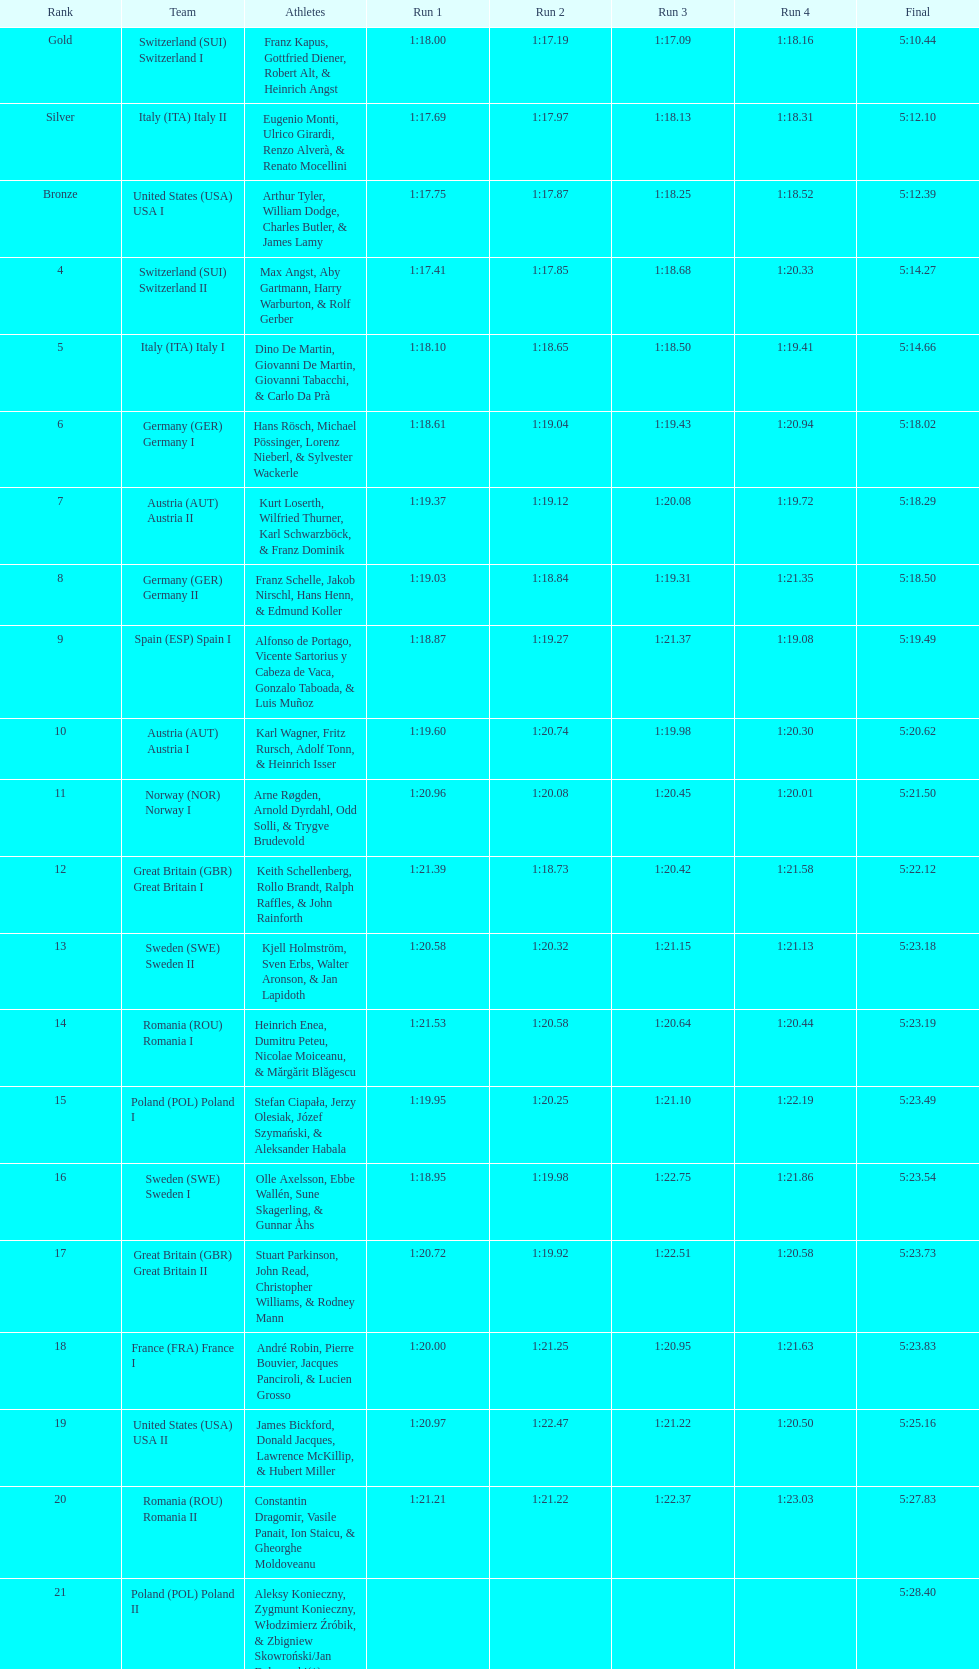Give me the full table as a dictionary. {'header': ['Rank', 'Team', 'Athletes', 'Run 1', 'Run 2', 'Run 3', 'Run 4', 'Final'], 'rows': [['Gold', 'Switzerland\xa0(SUI) Switzerland I', 'Franz Kapus, Gottfried Diener, Robert Alt, & Heinrich Angst', '1:18.00', '1:17.19', '1:17.09', '1:18.16', '5:10.44'], ['Silver', 'Italy\xa0(ITA) Italy II', 'Eugenio Monti, Ulrico Girardi, Renzo Alverà, & Renato Mocellini', '1:17.69', '1:17.97', '1:18.13', '1:18.31', '5:12.10'], ['Bronze', 'United States\xa0(USA) USA I', 'Arthur Tyler, William Dodge, Charles Butler, & James Lamy', '1:17.75', '1:17.87', '1:18.25', '1:18.52', '5:12.39'], ['4', 'Switzerland\xa0(SUI) Switzerland II', 'Max Angst, Aby Gartmann, Harry Warburton, & Rolf Gerber', '1:17.41', '1:17.85', '1:18.68', '1:20.33', '5:14.27'], ['5', 'Italy\xa0(ITA) Italy I', 'Dino De Martin, Giovanni De Martin, Giovanni Tabacchi, & Carlo Da Prà', '1:18.10', '1:18.65', '1:18.50', '1:19.41', '5:14.66'], ['6', 'Germany\xa0(GER) Germany I', 'Hans Rösch, Michael Pössinger, Lorenz Nieberl, & Sylvester Wackerle', '1:18.61', '1:19.04', '1:19.43', '1:20.94', '5:18.02'], ['7', 'Austria\xa0(AUT) Austria II', 'Kurt Loserth, Wilfried Thurner, Karl Schwarzböck, & Franz Dominik', '1:19.37', '1:19.12', '1:20.08', '1:19.72', '5:18.29'], ['8', 'Germany\xa0(GER) Germany II', 'Franz Schelle, Jakob Nirschl, Hans Henn, & Edmund Koller', '1:19.03', '1:18.84', '1:19.31', '1:21.35', '5:18.50'], ['9', 'Spain\xa0(ESP) Spain I', 'Alfonso de Portago, Vicente Sartorius y Cabeza de Vaca, Gonzalo Taboada, & Luis Muñoz', '1:18.87', '1:19.27', '1:21.37', '1:19.08', '5:19.49'], ['10', 'Austria\xa0(AUT) Austria I', 'Karl Wagner, Fritz Rursch, Adolf Tonn, & Heinrich Isser', '1:19.60', '1:20.74', '1:19.98', '1:20.30', '5:20.62'], ['11', 'Norway\xa0(NOR) Norway I', 'Arne Røgden, Arnold Dyrdahl, Odd Solli, & Trygve Brudevold', '1:20.96', '1:20.08', '1:20.45', '1:20.01', '5:21.50'], ['12', 'Great Britain\xa0(GBR) Great Britain I', 'Keith Schellenberg, Rollo Brandt, Ralph Raffles, & John Rainforth', '1:21.39', '1:18.73', '1:20.42', '1:21.58', '5:22.12'], ['13', 'Sweden\xa0(SWE) Sweden II', 'Kjell Holmström, Sven Erbs, Walter Aronson, & Jan Lapidoth', '1:20.58', '1:20.32', '1:21.15', '1:21.13', '5:23.18'], ['14', 'Romania\xa0(ROU) Romania I', 'Heinrich Enea, Dumitru Peteu, Nicolae Moiceanu, & Mărgărit Blăgescu', '1:21.53', '1:20.58', '1:20.64', '1:20.44', '5:23.19'], ['15', 'Poland\xa0(POL) Poland I', 'Stefan Ciapała, Jerzy Olesiak, Józef Szymański, & Aleksander Habala', '1:19.95', '1:20.25', '1:21.10', '1:22.19', '5:23.49'], ['16', 'Sweden\xa0(SWE) Sweden I', 'Olle Axelsson, Ebbe Wallén, Sune Skagerling, & Gunnar Åhs', '1:18.95', '1:19.98', '1:22.75', '1:21.86', '5:23.54'], ['17', 'Great Britain\xa0(GBR) Great Britain II', 'Stuart Parkinson, John Read, Christopher Williams, & Rodney Mann', '1:20.72', '1:19.92', '1:22.51', '1:20.58', '5:23.73'], ['18', 'France\xa0(FRA) France I', 'André Robin, Pierre Bouvier, Jacques Panciroli, & Lucien Grosso', '1:20.00', '1:21.25', '1:20.95', '1:21.63', '5:23.83'], ['19', 'United States\xa0(USA) USA II', 'James Bickford, Donald Jacques, Lawrence McKillip, & Hubert Miller', '1:20.97', '1:22.47', '1:21.22', '1:20.50', '5:25.16'], ['20', 'Romania\xa0(ROU) Romania II', 'Constantin Dragomir, Vasile Panait, Ion Staicu, & Gheorghe Moldoveanu', '1:21.21', '1:21.22', '1:22.37', '1:23.03', '5:27.83'], ['21', 'Poland\xa0(POL) Poland II', 'Aleksy Konieczny, Zygmunt Konieczny, Włodzimierz Źróbik, & Zbigniew Skowroński/Jan Dąbrowski(*)', '', '', '', '', '5:28.40']]} Who ranked higher, italy or germany? Italy. 